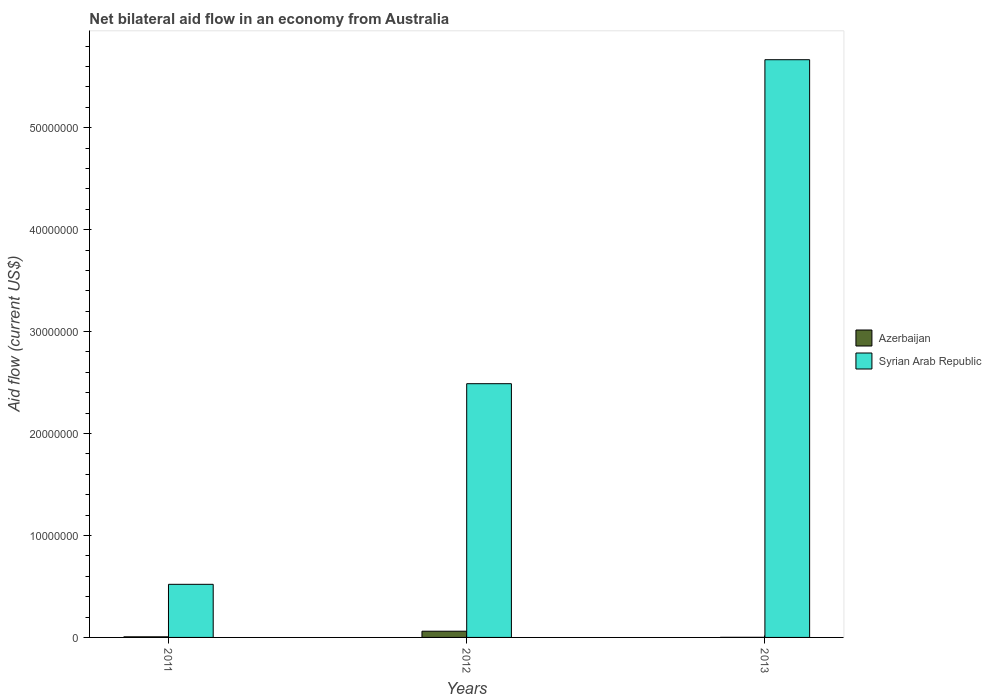How many different coloured bars are there?
Make the answer very short. 2. Are the number of bars per tick equal to the number of legend labels?
Your answer should be very brief. Yes. How many bars are there on the 3rd tick from the left?
Offer a very short reply. 2. What is the net bilateral aid flow in Azerbaijan in 2013?
Your answer should be very brief. 10000. Across all years, what is the maximum net bilateral aid flow in Syrian Arab Republic?
Keep it short and to the point. 5.67e+07. Across all years, what is the minimum net bilateral aid flow in Syrian Arab Republic?
Offer a terse response. 5.21e+06. In which year was the net bilateral aid flow in Azerbaijan minimum?
Your response must be concise. 2013. What is the total net bilateral aid flow in Azerbaijan in the graph?
Offer a terse response. 6.80e+05. What is the difference between the net bilateral aid flow in Azerbaijan in 2012 and that in 2013?
Make the answer very short. 6.00e+05. What is the difference between the net bilateral aid flow in Syrian Arab Republic in 2011 and the net bilateral aid flow in Azerbaijan in 2013?
Keep it short and to the point. 5.20e+06. What is the average net bilateral aid flow in Azerbaijan per year?
Give a very brief answer. 2.27e+05. In the year 2013, what is the difference between the net bilateral aid flow in Azerbaijan and net bilateral aid flow in Syrian Arab Republic?
Offer a terse response. -5.67e+07. In how many years, is the net bilateral aid flow in Syrian Arab Republic greater than 8000000 US$?
Make the answer very short. 2. What is the ratio of the net bilateral aid flow in Syrian Arab Republic in 2012 to that in 2013?
Provide a short and direct response. 0.44. Is the net bilateral aid flow in Azerbaijan in 2011 less than that in 2012?
Keep it short and to the point. Yes. Is the difference between the net bilateral aid flow in Azerbaijan in 2012 and 2013 greater than the difference between the net bilateral aid flow in Syrian Arab Republic in 2012 and 2013?
Give a very brief answer. Yes. What is the difference between the highest and the second highest net bilateral aid flow in Syrian Arab Republic?
Provide a short and direct response. 3.18e+07. What is the difference between the highest and the lowest net bilateral aid flow in Syrian Arab Republic?
Provide a short and direct response. 5.15e+07. In how many years, is the net bilateral aid flow in Azerbaijan greater than the average net bilateral aid flow in Azerbaijan taken over all years?
Ensure brevity in your answer.  1. Is the sum of the net bilateral aid flow in Azerbaijan in 2012 and 2013 greater than the maximum net bilateral aid flow in Syrian Arab Republic across all years?
Provide a succinct answer. No. What does the 2nd bar from the left in 2013 represents?
Your answer should be very brief. Syrian Arab Republic. What does the 2nd bar from the right in 2012 represents?
Offer a very short reply. Azerbaijan. How many bars are there?
Provide a succinct answer. 6. Where does the legend appear in the graph?
Your response must be concise. Center right. How many legend labels are there?
Make the answer very short. 2. How are the legend labels stacked?
Give a very brief answer. Vertical. What is the title of the graph?
Offer a terse response. Net bilateral aid flow in an economy from Australia. Does "Mali" appear as one of the legend labels in the graph?
Make the answer very short. No. What is the label or title of the Y-axis?
Give a very brief answer. Aid flow (current US$). What is the Aid flow (current US$) of Azerbaijan in 2011?
Make the answer very short. 6.00e+04. What is the Aid flow (current US$) of Syrian Arab Republic in 2011?
Ensure brevity in your answer.  5.21e+06. What is the Aid flow (current US$) of Syrian Arab Republic in 2012?
Offer a very short reply. 2.49e+07. What is the Aid flow (current US$) in Azerbaijan in 2013?
Your answer should be compact. 10000. What is the Aid flow (current US$) of Syrian Arab Republic in 2013?
Provide a succinct answer. 5.67e+07. Across all years, what is the maximum Aid flow (current US$) in Syrian Arab Republic?
Your answer should be compact. 5.67e+07. Across all years, what is the minimum Aid flow (current US$) of Syrian Arab Republic?
Keep it short and to the point. 5.21e+06. What is the total Aid flow (current US$) of Azerbaijan in the graph?
Offer a very short reply. 6.80e+05. What is the total Aid flow (current US$) in Syrian Arab Republic in the graph?
Provide a short and direct response. 8.68e+07. What is the difference between the Aid flow (current US$) in Azerbaijan in 2011 and that in 2012?
Keep it short and to the point. -5.50e+05. What is the difference between the Aid flow (current US$) in Syrian Arab Republic in 2011 and that in 2012?
Provide a succinct answer. -1.97e+07. What is the difference between the Aid flow (current US$) of Syrian Arab Republic in 2011 and that in 2013?
Give a very brief answer. -5.15e+07. What is the difference between the Aid flow (current US$) of Azerbaijan in 2012 and that in 2013?
Offer a terse response. 6.00e+05. What is the difference between the Aid flow (current US$) of Syrian Arab Republic in 2012 and that in 2013?
Ensure brevity in your answer.  -3.18e+07. What is the difference between the Aid flow (current US$) of Azerbaijan in 2011 and the Aid flow (current US$) of Syrian Arab Republic in 2012?
Offer a terse response. -2.48e+07. What is the difference between the Aid flow (current US$) of Azerbaijan in 2011 and the Aid flow (current US$) of Syrian Arab Republic in 2013?
Your response must be concise. -5.66e+07. What is the difference between the Aid flow (current US$) of Azerbaijan in 2012 and the Aid flow (current US$) of Syrian Arab Republic in 2013?
Keep it short and to the point. -5.61e+07. What is the average Aid flow (current US$) in Azerbaijan per year?
Offer a very short reply. 2.27e+05. What is the average Aid flow (current US$) of Syrian Arab Republic per year?
Your response must be concise. 2.89e+07. In the year 2011, what is the difference between the Aid flow (current US$) in Azerbaijan and Aid flow (current US$) in Syrian Arab Republic?
Provide a succinct answer. -5.15e+06. In the year 2012, what is the difference between the Aid flow (current US$) in Azerbaijan and Aid flow (current US$) in Syrian Arab Republic?
Offer a terse response. -2.43e+07. In the year 2013, what is the difference between the Aid flow (current US$) of Azerbaijan and Aid flow (current US$) of Syrian Arab Republic?
Make the answer very short. -5.67e+07. What is the ratio of the Aid flow (current US$) of Azerbaijan in 2011 to that in 2012?
Offer a terse response. 0.1. What is the ratio of the Aid flow (current US$) in Syrian Arab Republic in 2011 to that in 2012?
Offer a terse response. 0.21. What is the ratio of the Aid flow (current US$) in Syrian Arab Republic in 2011 to that in 2013?
Provide a short and direct response. 0.09. What is the ratio of the Aid flow (current US$) of Azerbaijan in 2012 to that in 2013?
Your response must be concise. 61. What is the ratio of the Aid flow (current US$) in Syrian Arab Republic in 2012 to that in 2013?
Provide a succinct answer. 0.44. What is the difference between the highest and the second highest Aid flow (current US$) in Azerbaijan?
Your answer should be very brief. 5.50e+05. What is the difference between the highest and the second highest Aid flow (current US$) of Syrian Arab Republic?
Give a very brief answer. 3.18e+07. What is the difference between the highest and the lowest Aid flow (current US$) of Syrian Arab Republic?
Ensure brevity in your answer.  5.15e+07. 